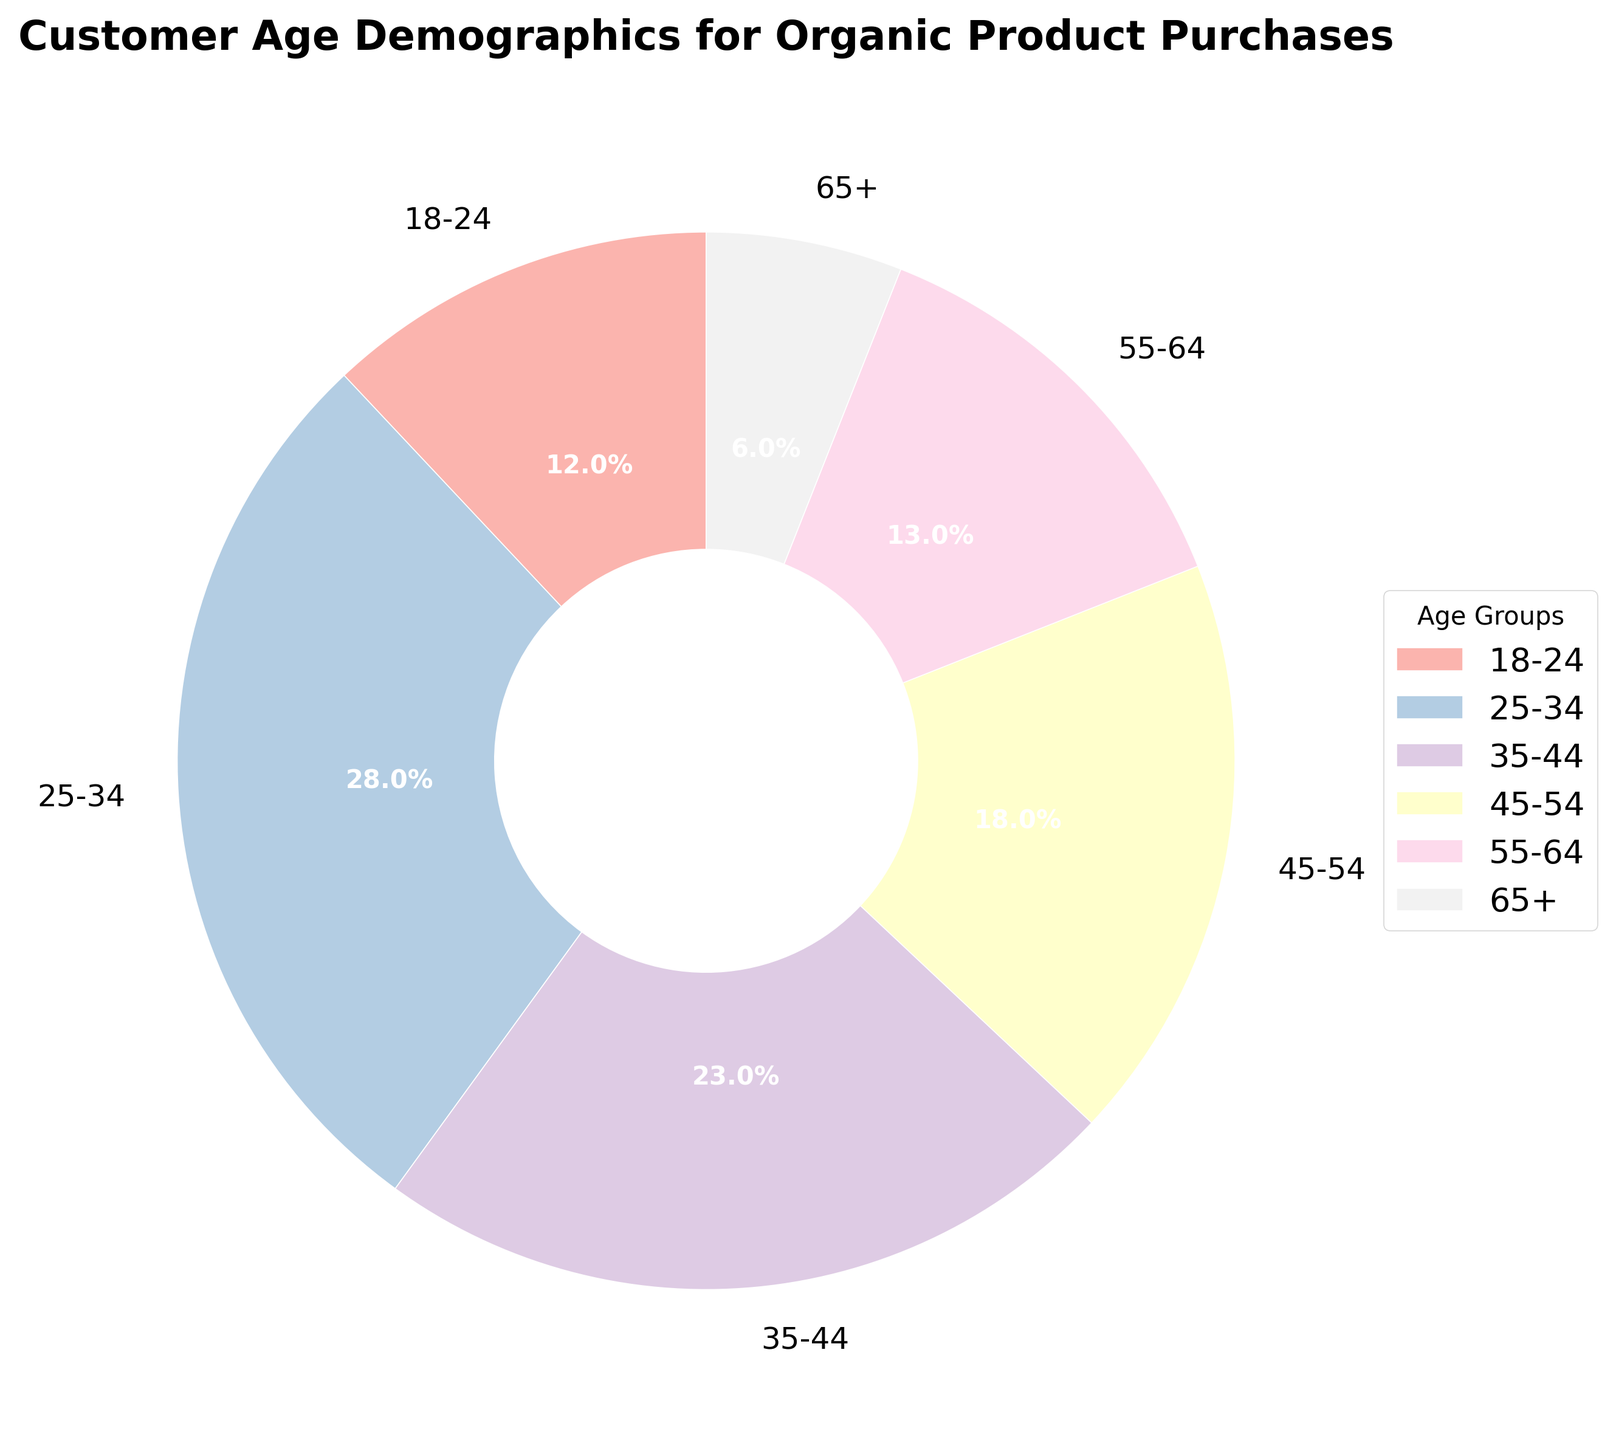What's the largest age group for organic product purchases? By looking at the pie chart, the largest section represents the 25-34 age group, which has the highest percentage.
Answer: 25-34 Which age group has the smallest percentage of organic product purchases? The smallest section of the pie chart represents the 65+ age group.
Answer: 65+ How much larger is the 25-34 age group compared to the 65+ age group? The 25-34 group is 28%, and the 65+ group is 6%. To find how much larger, subtract 6 from 28 (28 - 6 = 22).
Answer: 22% What is the combined percentage of the 35-44 and 45-54 age groups? The 35-44 age group is 23%, and the 45-54 age group is 18%. Adding them gives 23 + 18 = 41.
Answer: 41% Which age group has a percentage closer to the age group 18-24, between groups 55-64 and 65+? The 18-24 age group is 12%; the 55-64 group is 13%, and the 65+ group is 6%. The closer value to 12% is 13%.
Answer: 55-64 Which two age groups together make up more than half of the total purchases? The 25-34 group is 28% and the 35-44 group is 23%. Adding them gives 28 + 23 = 51, which is more than half.
Answer: 25-34 and 35-44 How many age groups have a percentage greater than 20%? By inspecting the pie chart, the age groups 25-34 (28%) and 35-44 (23%) are both greater than 20%. There are 2 such groups.
Answer: 2 How does the size of the 45-54 age group's section visually compare to the 18-24 age group's section? The 45-54 age group has 18%, and the 18-24 age group has 12%. The section for the 45-54 age group appears larger than the 18-24 group on the pie chart.
Answer: 45-54 group is larger What is the sum of the percentages of the oldest and youngest age groups? The 65+ age group is 6%, and the 18-24 age group is 12%. Adding them gives 6 + 12 = 18.
Answer: 18% Is the percentage of the 55-64 age group closer to that of the 18-24 age group or the 45-54 age group? The 55-64 age group is 13%, the 18-24 age group is 12%, and the 45-54 age group is 18%. The percentage of 13% is closer to 12% than to 18%.
Answer: 18-24 